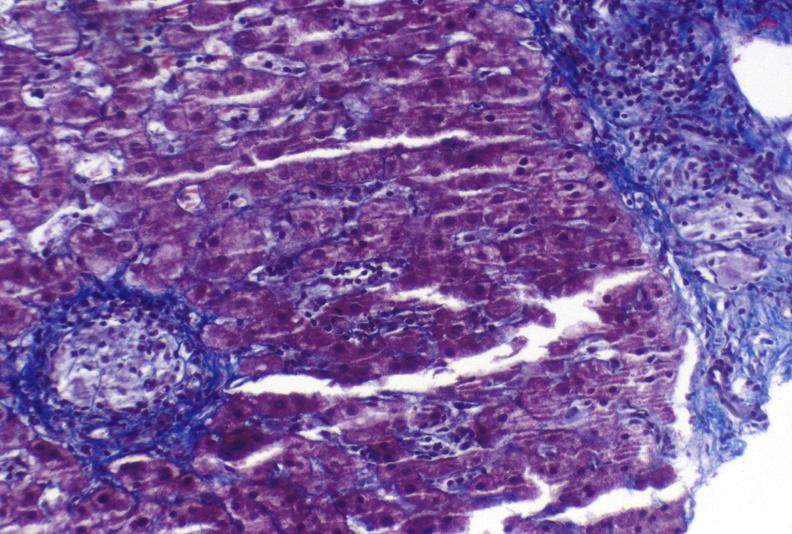does krukenberg tumor show sarcoid?
Answer the question using a single word or phrase. No 